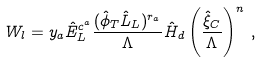Convert formula to latex. <formula><loc_0><loc_0><loc_500><loc_500>W _ { l } = y _ { a } \hat { E } ^ { c ^ { a } } _ { L } \frac { ( \hat { \phi } _ { T } \hat { L } _ { L } ) ^ { r _ { a } } } { \Lambda } \hat { H } _ { d } \left ( \frac { \hat { \xi } _ { C } } { \Lambda } \right ) ^ { n } \, ,</formula> 